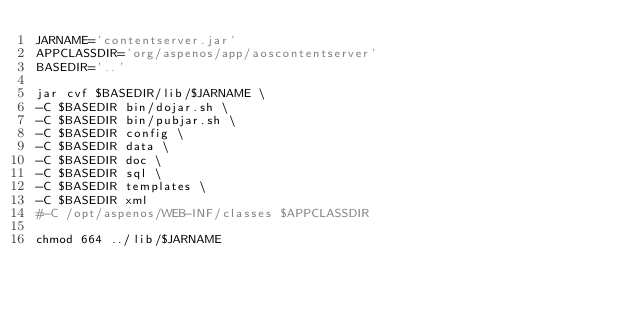Convert code to text. <code><loc_0><loc_0><loc_500><loc_500><_Bash_>JARNAME='contentserver.jar'
APPCLASSDIR='org/aspenos/app/aoscontentserver'
BASEDIR='..'

jar cvf $BASEDIR/lib/$JARNAME \
-C $BASEDIR bin/dojar.sh \
-C $BASEDIR bin/pubjar.sh \
-C $BASEDIR config \
-C $BASEDIR data \
-C $BASEDIR doc \
-C $BASEDIR sql \
-C $BASEDIR templates \
-C $BASEDIR xml
#-C /opt/aspenos/WEB-INF/classes $APPCLASSDIR

chmod 664 ../lib/$JARNAME

</code> 